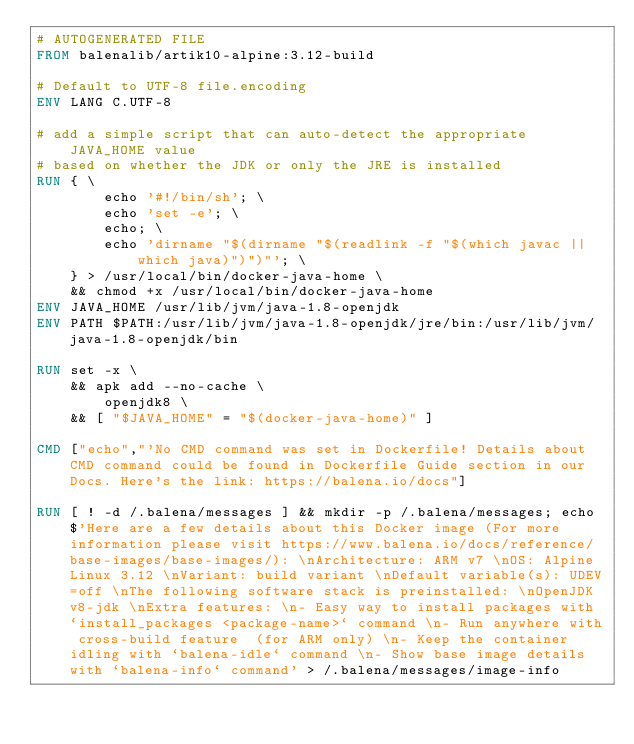<code> <loc_0><loc_0><loc_500><loc_500><_Dockerfile_># AUTOGENERATED FILE
FROM balenalib/artik10-alpine:3.12-build

# Default to UTF-8 file.encoding
ENV LANG C.UTF-8

# add a simple script that can auto-detect the appropriate JAVA_HOME value
# based on whether the JDK or only the JRE is installed
RUN { \
		echo '#!/bin/sh'; \
		echo 'set -e'; \
		echo; \
		echo 'dirname "$(dirname "$(readlink -f "$(which javac || which java)")")"'; \
	} > /usr/local/bin/docker-java-home \
	&& chmod +x /usr/local/bin/docker-java-home
ENV JAVA_HOME /usr/lib/jvm/java-1.8-openjdk
ENV PATH $PATH:/usr/lib/jvm/java-1.8-openjdk/jre/bin:/usr/lib/jvm/java-1.8-openjdk/bin

RUN set -x \
	&& apk add --no-cache \
		openjdk8 \
	&& [ "$JAVA_HOME" = "$(docker-java-home)" ]

CMD ["echo","'No CMD command was set in Dockerfile! Details about CMD command could be found in Dockerfile Guide section in our Docs. Here's the link: https://balena.io/docs"]

RUN [ ! -d /.balena/messages ] && mkdir -p /.balena/messages; echo $'Here are a few details about this Docker image (For more information please visit https://www.balena.io/docs/reference/base-images/base-images/): \nArchitecture: ARM v7 \nOS: Alpine Linux 3.12 \nVariant: build variant \nDefault variable(s): UDEV=off \nThe following software stack is preinstalled: \nOpenJDK v8-jdk \nExtra features: \n- Easy way to install packages with `install_packages <package-name>` command \n- Run anywhere with cross-build feature  (for ARM only) \n- Keep the container idling with `balena-idle` command \n- Show base image details with `balena-info` command' > /.balena/messages/image-info</code> 